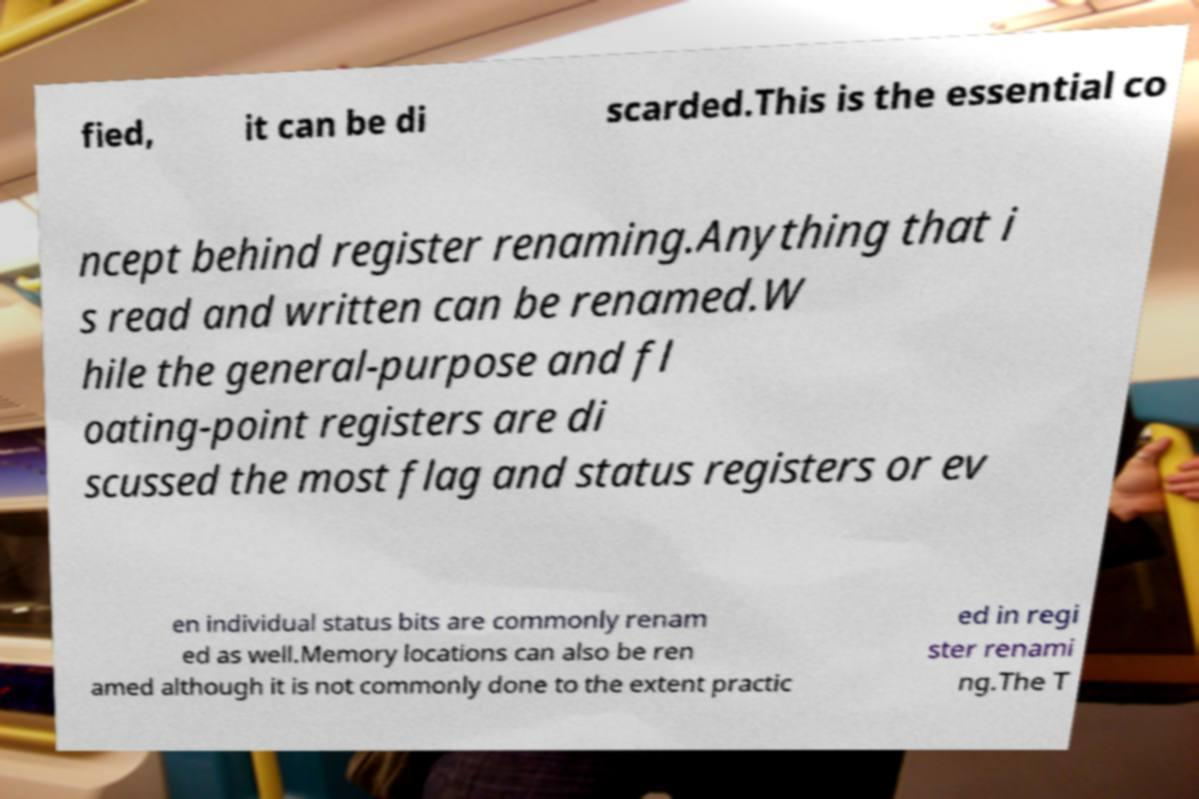For documentation purposes, I need the text within this image transcribed. Could you provide that? fied, it can be di scarded.This is the essential co ncept behind register renaming.Anything that i s read and written can be renamed.W hile the general-purpose and fl oating-point registers are di scussed the most flag and status registers or ev en individual status bits are commonly renam ed as well.Memory locations can also be ren amed although it is not commonly done to the extent practic ed in regi ster renami ng.The T 